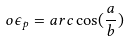<formula> <loc_0><loc_0><loc_500><loc_500>o \epsilon _ { p } = a r c \cos ( \frac { a } { b } )</formula> 